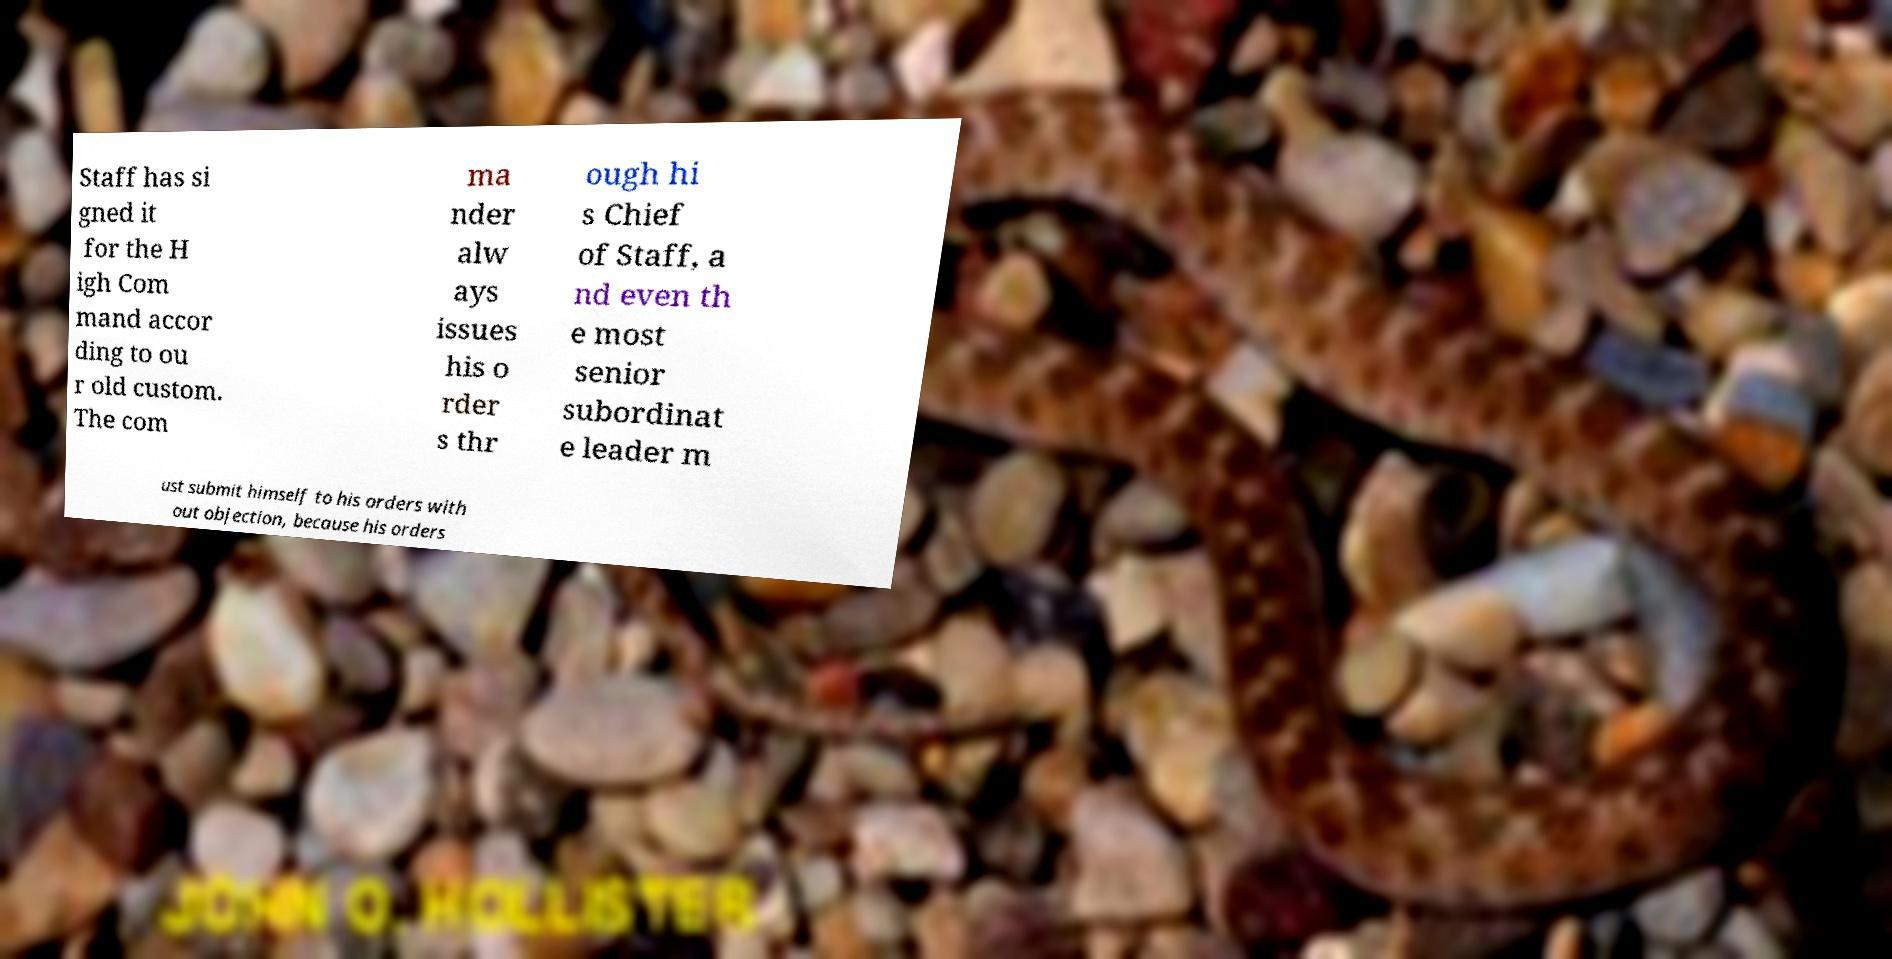Can you accurately transcribe the text from the provided image for me? Staff has si gned it for the H igh Com mand accor ding to ou r old custom. The com ma nder alw ays issues his o rder s thr ough hi s Chief of Staff, a nd even th e most senior subordinat e leader m ust submit himself to his orders with out objection, because his orders 